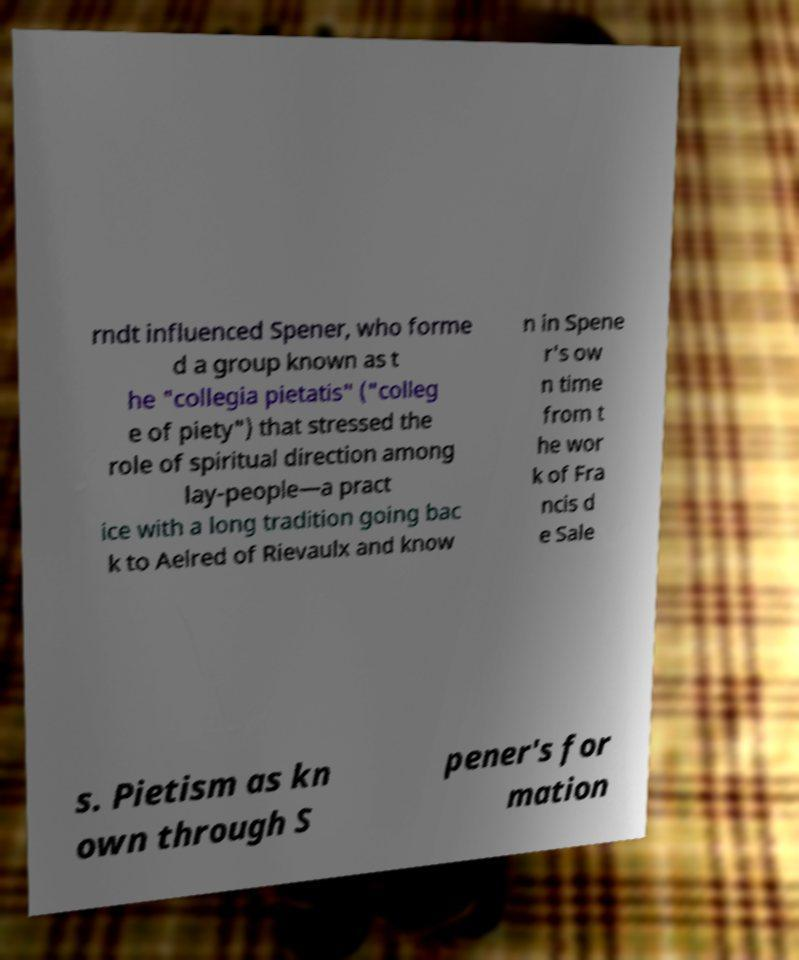Could you extract and type out the text from this image? rndt influenced Spener, who forme d a group known as t he "collegia pietatis" ("colleg e of piety") that stressed the role of spiritual direction among lay-people—a pract ice with a long tradition going bac k to Aelred of Rievaulx and know n in Spene r's ow n time from t he wor k of Fra ncis d e Sale s. Pietism as kn own through S pener's for mation 